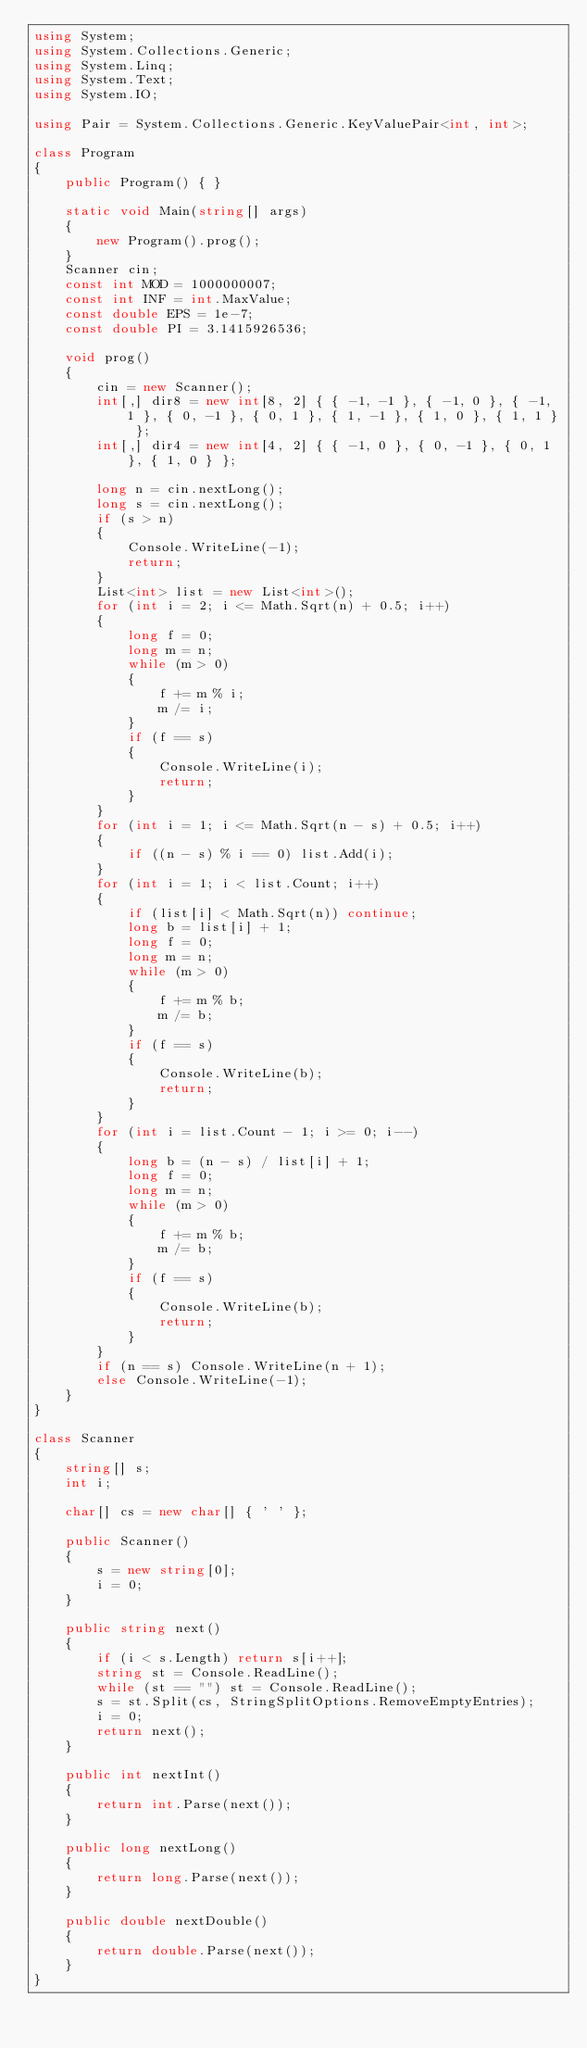<code> <loc_0><loc_0><loc_500><loc_500><_C#_>using System;
using System.Collections.Generic;
using System.Linq;
using System.Text;
using System.IO;

using Pair = System.Collections.Generic.KeyValuePair<int, int>;

class Program
{
	public Program() { }

	static void Main(string[] args)
	{
		new Program().prog();
	}
	Scanner cin;
	const int MOD = 1000000007;
	const int INF = int.MaxValue;
	const double EPS = 1e-7;
	const double PI = 3.1415926536;

	void prog()
	{
		cin = new Scanner();
		int[,] dir8 = new int[8, 2] { { -1, -1 }, { -1, 0 }, { -1, 1 }, { 0, -1 }, { 0, 1 }, { 1, -1 }, { 1, 0 }, { 1, 1 } };
		int[,] dir4 = new int[4, 2] { { -1, 0 }, { 0, -1 }, { 0, 1 }, { 1, 0 } };

		long n = cin.nextLong();
		long s = cin.nextLong();
		if (s > n)
		{
			Console.WriteLine(-1);
			return;
		}
		List<int> list = new List<int>();
		for (int i = 2; i <= Math.Sqrt(n) + 0.5; i++)
		{
			long f = 0;
			long m = n;
			while (m > 0)
			{
				f += m % i;
				m /= i;
			}
			if (f == s)
			{
				Console.WriteLine(i);
				return;
			}
		}
		for (int i = 1; i <= Math.Sqrt(n - s) + 0.5; i++)
		{
			if ((n - s) % i == 0) list.Add(i);
		}
		for (int i = 1; i < list.Count; i++)
		{
			if (list[i] < Math.Sqrt(n)) continue;
			long b = list[i] + 1;
			long f = 0;
			long m = n;
			while (m > 0)
			{
				f += m % b;
				m /= b;
			}
			if (f == s)
			{
				Console.WriteLine(b);
				return;
			}
		}
		for (int i = list.Count - 1; i >= 0; i--)
		{
			long b = (n - s) / list[i] + 1;
			long f = 0;
			long m = n;
			while (m > 0)
			{
				f += m % b;
				m /= b;
			}
			if (f == s)
			{
				Console.WriteLine(b);
				return;
			}
		}
		if (n == s) Console.WriteLine(n + 1);
		else Console.WriteLine(-1);
	}
}

class Scanner
{
	string[] s;
	int i;

	char[] cs = new char[] { ' ' };

	public Scanner()
	{
		s = new string[0];
		i = 0;
	}

	public string next()
	{
		if (i < s.Length) return s[i++];
		string st = Console.ReadLine();
		while (st == "") st = Console.ReadLine();
		s = st.Split(cs, StringSplitOptions.RemoveEmptyEntries);
		i = 0;
		return next();
	}

	public int nextInt()
	{
		return int.Parse(next());
	}

	public long nextLong()
	{
		return long.Parse(next());
	}

	public double nextDouble()
	{
		return double.Parse(next());
	}
}</code> 